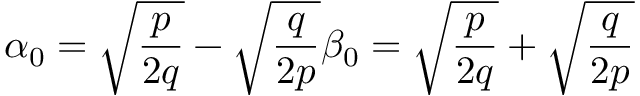<formula> <loc_0><loc_0><loc_500><loc_500>\alpha _ { 0 } = \sqrt { { \frac { p } { 2 q } } } - \sqrt { { \frac { q } { 2 p } } } \beta _ { 0 } = \sqrt { { \frac { p } { 2 q } } } + \sqrt { { \frac { q } { 2 p } } }</formula> 